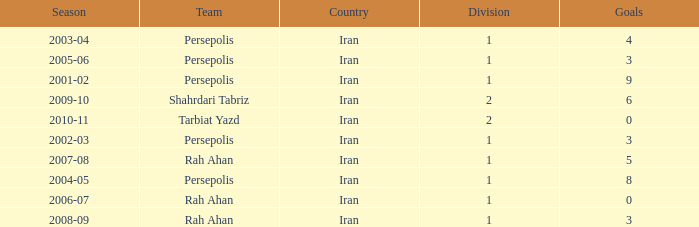What is the average Goals, when Team is "Rah Ahan", and when Division is less than 1? None. 